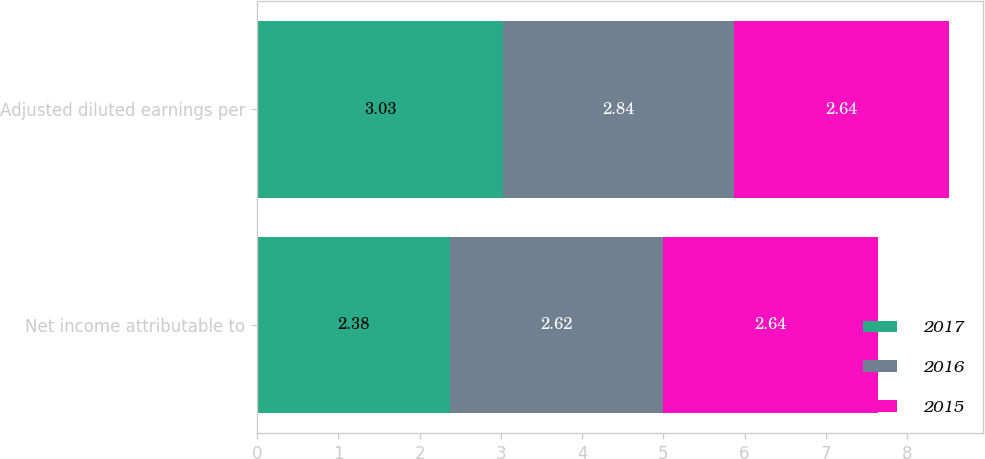Convert chart. <chart><loc_0><loc_0><loc_500><loc_500><stacked_bar_chart><ecel><fcel>Net income attributable to<fcel>Adjusted diluted earnings per<nl><fcel>2017<fcel>2.38<fcel>3.03<nl><fcel>2016<fcel>2.62<fcel>2.84<nl><fcel>2015<fcel>2.64<fcel>2.64<nl></chart> 